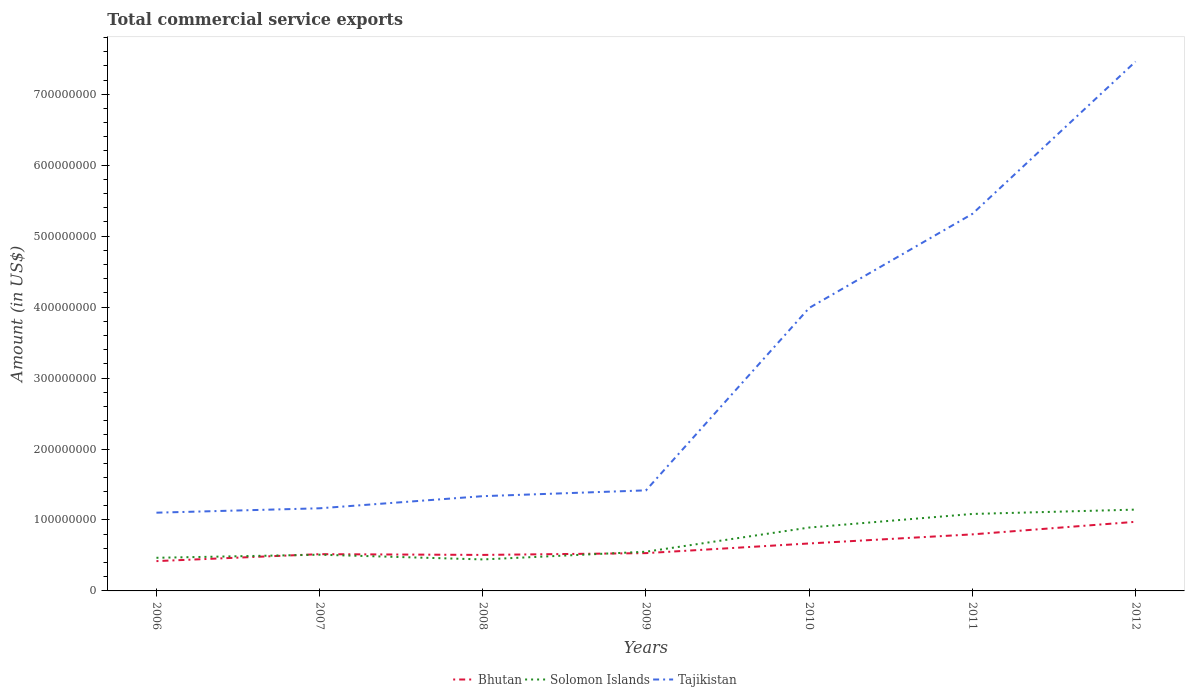How many different coloured lines are there?
Ensure brevity in your answer.  3. Is the number of lines equal to the number of legend labels?
Make the answer very short. Yes. Across all years, what is the maximum total commercial service exports in Solomon Islands?
Your response must be concise. 4.44e+07. In which year was the total commercial service exports in Tajikistan maximum?
Your response must be concise. 2006. What is the total total commercial service exports in Solomon Islands in the graph?
Give a very brief answer. -6.13e+06. What is the difference between the highest and the second highest total commercial service exports in Tajikistan?
Provide a short and direct response. 6.36e+08. What is the difference between the highest and the lowest total commercial service exports in Tajikistan?
Provide a succinct answer. 3. How many lines are there?
Your response must be concise. 3. How many years are there in the graph?
Give a very brief answer. 7. What is the difference between two consecutive major ticks on the Y-axis?
Provide a short and direct response. 1.00e+08. Are the values on the major ticks of Y-axis written in scientific E-notation?
Make the answer very short. No. How are the legend labels stacked?
Ensure brevity in your answer.  Horizontal. What is the title of the graph?
Keep it short and to the point. Total commercial service exports. Does "Liechtenstein" appear as one of the legend labels in the graph?
Your response must be concise. No. What is the label or title of the X-axis?
Offer a terse response. Years. What is the label or title of the Y-axis?
Offer a terse response. Amount (in US$). What is the Amount (in US$) of Bhutan in 2006?
Your response must be concise. 4.20e+07. What is the Amount (in US$) in Solomon Islands in 2006?
Give a very brief answer. 4.67e+07. What is the Amount (in US$) of Tajikistan in 2006?
Give a very brief answer. 1.10e+08. What is the Amount (in US$) of Bhutan in 2007?
Ensure brevity in your answer.  5.18e+07. What is the Amount (in US$) in Solomon Islands in 2007?
Your response must be concise. 5.10e+07. What is the Amount (in US$) in Tajikistan in 2007?
Your answer should be very brief. 1.16e+08. What is the Amount (in US$) of Bhutan in 2008?
Offer a terse response. 5.07e+07. What is the Amount (in US$) of Solomon Islands in 2008?
Your answer should be very brief. 4.44e+07. What is the Amount (in US$) of Tajikistan in 2008?
Give a very brief answer. 1.34e+08. What is the Amount (in US$) in Bhutan in 2009?
Give a very brief answer. 5.33e+07. What is the Amount (in US$) of Solomon Islands in 2009?
Ensure brevity in your answer.  5.53e+07. What is the Amount (in US$) of Tajikistan in 2009?
Make the answer very short. 1.42e+08. What is the Amount (in US$) in Bhutan in 2010?
Make the answer very short. 6.69e+07. What is the Amount (in US$) of Solomon Islands in 2010?
Provide a succinct answer. 8.93e+07. What is the Amount (in US$) in Tajikistan in 2010?
Provide a short and direct response. 3.99e+08. What is the Amount (in US$) in Bhutan in 2011?
Make the answer very short. 7.97e+07. What is the Amount (in US$) in Solomon Islands in 2011?
Provide a succinct answer. 1.08e+08. What is the Amount (in US$) in Tajikistan in 2011?
Your answer should be very brief. 5.31e+08. What is the Amount (in US$) in Bhutan in 2012?
Provide a succinct answer. 9.74e+07. What is the Amount (in US$) in Solomon Islands in 2012?
Your answer should be compact. 1.15e+08. What is the Amount (in US$) in Tajikistan in 2012?
Ensure brevity in your answer.  7.46e+08. Across all years, what is the maximum Amount (in US$) in Bhutan?
Offer a very short reply. 9.74e+07. Across all years, what is the maximum Amount (in US$) in Solomon Islands?
Offer a terse response. 1.15e+08. Across all years, what is the maximum Amount (in US$) of Tajikistan?
Make the answer very short. 7.46e+08. Across all years, what is the minimum Amount (in US$) of Bhutan?
Give a very brief answer. 4.20e+07. Across all years, what is the minimum Amount (in US$) of Solomon Islands?
Ensure brevity in your answer.  4.44e+07. Across all years, what is the minimum Amount (in US$) in Tajikistan?
Provide a succinct answer. 1.10e+08. What is the total Amount (in US$) in Bhutan in the graph?
Provide a short and direct response. 4.42e+08. What is the total Amount (in US$) in Solomon Islands in the graph?
Keep it short and to the point. 5.10e+08. What is the total Amount (in US$) of Tajikistan in the graph?
Your answer should be very brief. 2.18e+09. What is the difference between the Amount (in US$) in Bhutan in 2006 and that in 2007?
Make the answer very short. -9.80e+06. What is the difference between the Amount (in US$) in Solomon Islands in 2006 and that in 2007?
Keep it short and to the point. -4.36e+06. What is the difference between the Amount (in US$) in Tajikistan in 2006 and that in 2007?
Provide a short and direct response. -6.20e+06. What is the difference between the Amount (in US$) in Bhutan in 2006 and that in 2008?
Offer a terse response. -8.72e+06. What is the difference between the Amount (in US$) of Solomon Islands in 2006 and that in 2008?
Your answer should be compact. 2.32e+06. What is the difference between the Amount (in US$) of Tajikistan in 2006 and that in 2008?
Provide a succinct answer. -2.33e+07. What is the difference between the Amount (in US$) of Bhutan in 2006 and that in 2009?
Your answer should be very brief. -1.13e+07. What is the difference between the Amount (in US$) in Solomon Islands in 2006 and that in 2009?
Keep it short and to the point. -8.57e+06. What is the difference between the Amount (in US$) of Tajikistan in 2006 and that in 2009?
Provide a succinct answer. -3.15e+07. What is the difference between the Amount (in US$) of Bhutan in 2006 and that in 2010?
Offer a very short reply. -2.49e+07. What is the difference between the Amount (in US$) in Solomon Islands in 2006 and that in 2010?
Give a very brief answer. -4.26e+07. What is the difference between the Amount (in US$) in Tajikistan in 2006 and that in 2010?
Your answer should be very brief. -2.89e+08. What is the difference between the Amount (in US$) of Bhutan in 2006 and that in 2011?
Make the answer very short. -3.77e+07. What is the difference between the Amount (in US$) of Solomon Islands in 2006 and that in 2011?
Ensure brevity in your answer.  -6.18e+07. What is the difference between the Amount (in US$) of Tajikistan in 2006 and that in 2011?
Provide a short and direct response. -4.21e+08. What is the difference between the Amount (in US$) in Bhutan in 2006 and that in 2012?
Make the answer very short. -5.54e+07. What is the difference between the Amount (in US$) in Solomon Islands in 2006 and that in 2012?
Keep it short and to the point. -6.79e+07. What is the difference between the Amount (in US$) of Tajikistan in 2006 and that in 2012?
Your response must be concise. -6.36e+08. What is the difference between the Amount (in US$) in Bhutan in 2007 and that in 2008?
Ensure brevity in your answer.  1.08e+06. What is the difference between the Amount (in US$) of Solomon Islands in 2007 and that in 2008?
Make the answer very short. 6.67e+06. What is the difference between the Amount (in US$) in Tajikistan in 2007 and that in 2008?
Offer a terse response. -1.71e+07. What is the difference between the Amount (in US$) in Bhutan in 2007 and that in 2009?
Make the answer very short. -1.45e+06. What is the difference between the Amount (in US$) in Solomon Islands in 2007 and that in 2009?
Give a very brief answer. -4.21e+06. What is the difference between the Amount (in US$) in Tajikistan in 2007 and that in 2009?
Provide a succinct answer. -2.53e+07. What is the difference between the Amount (in US$) of Bhutan in 2007 and that in 2010?
Offer a very short reply. -1.51e+07. What is the difference between the Amount (in US$) in Solomon Islands in 2007 and that in 2010?
Your answer should be compact. -3.83e+07. What is the difference between the Amount (in US$) in Tajikistan in 2007 and that in 2010?
Offer a very short reply. -2.82e+08. What is the difference between the Amount (in US$) in Bhutan in 2007 and that in 2011?
Give a very brief answer. -2.79e+07. What is the difference between the Amount (in US$) of Solomon Islands in 2007 and that in 2011?
Provide a succinct answer. -5.74e+07. What is the difference between the Amount (in US$) of Tajikistan in 2007 and that in 2011?
Offer a very short reply. -4.15e+08. What is the difference between the Amount (in US$) of Bhutan in 2007 and that in 2012?
Your answer should be compact. -4.56e+07. What is the difference between the Amount (in US$) in Solomon Islands in 2007 and that in 2012?
Your response must be concise. -6.35e+07. What is the difference between the Amount (in US$) in Tajikistan in 2007 and that in 2012?
Make the answer very short. -6.30e+08. What is the difference between the Amount (in US$) in Bhutan in 2008 and that in 2009?
Your answer should be compact. -2.53e+06. What is the difference between the Amount (in US$) in Solomon Islands in 2008 and that in 2009?
Your answer should be compact. -1.09e+07. What is the difference between the Amount (in US$) in Tajikistan in 2008 and that in 2009?
Offer a very short reply. -8.19e+06. What is the difference between the Amount (in US$) in Bhutan in 2008 and that in 2010?
Provide a short and direct response. -1.62e+07. What is the difference between the Amount (in US$) of Solomon Islands in 2008 and that in 2010?
Ensure brevity in your answer.  -4.49e+07. What is the difference between the Amount (in US$) of Tajikistan in 2008 and that in 2010?
Your response must be concise. -2.65e+08. What is the difference between the Amount (in US$) of Bhutan in 2008 and that in 2011?
Your answer should be compact. -2.90e+07. What is the difference between the Amount (in US$) of Solomon Islands in 2008 and that in 2011?
Provide a succinct answer. -6.41e+07. What is the difference between the Amount (in US$) of Tajikistan in 2008 and that in 2011?
Offer a very short reply. -3.98e+08. What is the difference between the Amount (in US$) of Bhutan in 2008 and that in 2012?
Ensure brevity in your answer.  -4.67e+07. What is the difference between the Amount (in US$) of Solomon Islands in 2008 and that in 2012?
Provide a short and direct response. -7.02e+07. What is the difference between the Amount (in US$) of Tajikistan in 2008 and that in 2012?
Make the answer very short. -6.12e+08. What is the difference between the Amount (in US$) in Bhutan in 2009 and that in 2010?
Your answer should be very brief. -1.36e+07. What is the difference between the Amount (in US$) of Solomon Islands in 2009 and that in 2010?
Your response must be concise. -3.41e+07. What is the difference between the Amount (in US$) of Tajikistan in 2009 and that in 2010?
Make the answer very short. -2.57e+08. What is the difference between the Amount (in US$) of Bhutan in 2009 and that in 2011?
Offer a terse response. -2.64e+07. What is the difference between the Amount (in US$) of Solomon Islands in 2009 and that in 2011?
Your answer should be very brief. -5.32e+07. What is the difference between the Amount (in US$) in Tajikistan in 2009 and that in 2011?
Give a very brief answer. -3.90e+08. What is the difference between the Amount (in US$) of Bhutan in 2009 and that in 2012?
Your response must be concise. -4.41e+07. What is the difference between the Amount (in US$) in Solomon Islands in 2009 and that in 2012?
Your answer should be compact. -5.93e+07. What is the difference between the Amount (in US$) in Tajikistan in 2009 and that in 2012?
Provide a short and direct response. -6.04e+08. What is the difference between the Amount (in US$) in Bhutan in 2010 and that in 2011?
Your answer should be compact. -1.28e+07. What is the difference between the Amount (in US$) of Solomon Islands in 2010 and that in 2011?
Your answer should be compact. -1.91e+07. What is the difference between the Amount (in US$) of Tajikistan in 2010 and that in 2011?
Your response must be concise. -1.33e+08. What is the difference between the Amount (in US$) of Bhutan in 2010 and that in 2012?
Keep it short and to the point. -3.05e+07. What is the difference between the Amount (in US$) in Solomon Islands in 2010 and that in 2012?
Give a very brief answer. -2.53e+07. What is the difference between the Amount (in US$) of Tajikistan in 2010 and that in 2012?
Offer a terse response. -3.47e+08. What is the difference between the Amount (in US$) in Bhutan in 2011 and that in 2012?
Offer a terse response. -1.77e+07. What is the difference between the Amount (in US$) in Solomon Islands in 2011 and that in 2012?
Give a very brief answer. -6.13e+06. What is the difference between the Amount (in US$) in Tajikistan in 2011 and that in 2012?
Your answer should be compact. -2.15e+08. What is the difference between the Amount (in US$) of Bhutan in 2006 and the Amount (in US$) of Solomon Islands in 2007?
Provide a succinct answer. -9.04e+06. What is the difference between the Amount (in US$) of Bhutan in 2006 and the Amount (in US$) of Tajikistan in 2007?
Provide a short and direct response. -7.44e+07. What is the difference between the Amount (in US$) of Solomon Islands in 2006 and the Amount (in US$) of Tajikistan in 2007?
Provide a succinct answer. -6.98e+07. What is the difference between the Amount (in US$) of Bhutan in 2006 and the Amount (in US$) of Solomon Islands in 2008?
Your response must be concise. -2.36e+06. What is the difference between the Amount (in US$) of Bhutan in 2006 and the Amount (in US$) of Tajikistan in 2008?
Ensure brevity in your answer.  -9.15e+07. What is the difference between the Amount (in US$) of Solomon Islands in 2006 and the Amount (in US$) of Tajikistan in 2008?
Provide a succinct answer. -8.69e+07. What is the difference between the Amount (in US$) in Bhutan in 2006 and the Amount (in US$) in Solomon Islands in 2009?
Give a very brief answer. -1.32e+07. What is the difference between the Amount (in US$) of Bhutan in 2006 and the Amount (in US$) of Tajikistan in 2009?
Offer a very short reply. -9.97e+07. What is the difference between the Amount (in US$) in Solomon Islands in 2006 and the Amount (in US$) in Tajikistan in 2009?
Keep it short and to the point. -9.50e+07. What is the difference between the Amount (in US$) of Bhutan in 2006 and the Amount (in US$) of Solomon Islands in 2010?
Keep it short and to the point. -4.73e+07. What is the difference between the Amount (in US$) in Bhutan in 2006 and the Amount (in US$) in Tajikistan in 2010?
Ensure brevity in your answer.  -3.57e+08. What is the difference between the Amount (in US$) in Solomon Islands in 2006 and the Amount (in US$) in Tajikistan in 2010?
Give a very brief answer. -3.52e+08. What is the difference between the Amount (in US$) of Bhutan in 2006 and the Amount (in US$) of Solomon Islands in 2011?
Provide a succinct answer. -6.65e+07. What is the difference between the Amount (in US$) of Bhutan in 2006 and the Amount (in US$) of Tajikistan in 2011?
Keep it short and to the point. -4.89e+08. What is the difference between the Amount (in US$) of Solomon Islands in 2006 and the Amount (in US$) of Tajikistan in 2011?
Ensure brevity in your answer.  -4.85e+08. What is the difference between the Amount (in US$) in Bhutan in 2006 and the Amount (in US$) in Solomon Islands in 2012?
Give a very brief answer. -7.26e+07. What is the difference between the Amount (in US$) in Bhutan in 2006 and the Amount (in US$) in Tajikistan in 2012?
Provide a succinct answer. -7.04e+08. What is the difference between the Amount (in US$) of Solomon Islands in 2006 and the Amount (in US$) of Tajikistan in 2012?
Make the answer very short. -6.99e+08. What is the difference between the Amount (in US$) in Bhutan in 2007 and the Amount (in US$) in Solomon Islands in 2008?
Your answer should be very brief. 7.44e+06. What is the difference between the Amount (in US$) in Bhutan in 2007 and the Amount (in US$) in Tajikistan in 2008?
Make the answer very short. -8.17e+07. What is the difference between the Amount (in US$) in Solomon Islands in 2007 and the Amount (in US$) in Tajikistan in 2008?
Give a very brief answer. -8.25e+07. What is the difference between the Amount (in US$) in Bhutan in 2007 and the Amount (in US$) in Solomon Islands in 2009?
Give a very brief answer. -3.44e+06. What is the difference between the Amount (in US$) in Bhutan in 2007 and the Amount (in US$) in Tajikistan in 2009?
Make the answer very short. -8.99e+07. What is the difference between the Amount (in US$) of Solomon Islands in 2007 and the Amount (in US$) of Tajikistan in 2009?
Provide a succinct answer. -9.07e+07. What is the difference between the Amount (in US$) in Bhutan in 2007 and the Amount (in US$) in Solomon Islands in 2010?
Provide a short and direct response. -3.75e+07. What is the difference between the Amount (in US$) of Bhutan in 2007 and the Amount (in US$) of Tajikistan in 2010?
Offer a very short reply. -3.47e+08. What is the difference between the Amount (in US$) in Solomon Islands in 2007 and the Amount (in US$) in Tajikistan in 2010?
Your answer should be very brief. -3.48e+08. What is the difference between the Amount (in US$) in Bhutan in 2007 and the Amount (in US$) in Solomon Islands in 2011?
Your response must be concise. -5.66e+07. What is the difference between the Amount (in US$) in Bhutan in 2007 and the Amount (in US$) in Tajikistan in 2011?
Provide a succinct answer. -4.80e+08. What is the difference between the Amount (in US$) of Solomon Islands in 2007 and the Amount (in US$) of Tajikistan in 2011?
Your response must be concise. -4.80e+08. What is the difference between the Amount (in US$) in Bhutan in 2007 and the Amount (in US$) in Solomon Islands in 2012?
Offer a very short reply. -6.28e+07. What is the difference between the Amount (in US$) of Bhutan in 2007 and the Amount (in US$) of Tajikistan in 2012?
Your answer should be compact. -6.94e+08. What is the difference between the Amount (in US$) of Solomon Islands in 2007 and the Amount (in US$) of Tajikistan in 2012?
Ensure brevity in your answer.  -6.95e+08. What is the difference between the Amount (in US$) of Bhutan in 2008 and the Amount (in US$) of Solomon Islands in 2009?
Ensure brevity in your answer.  -4.53e+06. What is the difference between the Amount (in US$) of Bhutan in 2008 and the Amount (in US$) of Tajikistan in 2009?
Provide a succinct answer. -9.10e+07. What is the difference between the Amount (in US$) of Solomon Islands in 2008 and the Amount (in US$) of Tajikistan in 2009?
Keep it short and to the point. -9.74e+07. What is the difference between the Amount (in US$) in Bhutan in 2008 and the Amount (in US$) in Solomon Islands in 2010?
Your response must be concise. -3.86e+07. What is the difference between the Amount (in US$) in Bhutan in 2008 and the Amount (in US$) in Tajikistan in 2010?
Your answer should be compact. -3.48e+08. What is the difference between the Amount (in US$) of Solomon Islands in 2008 and the Amount (in US$) of Tajikistan in 2010?
Provide a short and direct response. -3.54e+08. What is the difference between the Amount (in US$) in Bhutan in 2008 and the Amount (in US$) in Solomon Islands in 2011?
Offer a terse response. -5.77e+07. What is the difference between the Amount (in US$) in Bhutan in 2008 and the Amount (in US$) in Tajikistan in 2011?
Ensure brevity in your answer.  -4.81e+08. What is the difference between the Amount (in US$) of Solomon Islands in 2008 and the Amount (in US$) of Tajikistan in 2011?
Give a very brief answer. -4.87e+08. What is the difference between the Amount (in US$) in Bhutan in 2008 and the Amount (in US$) in Solomon Islands in 2012?
Offer a very short reply. -6.39e+07. What is the difference between the Amount (in US$) of Bhutan in 2008 and the Amount (in US$) of Tajikistan in 2012?
Provide a succinct answer. -6.95e+08. What is the difference between the Amount (in US$) of Solomon Islands in 2008 and the Amount (in US$) of Tajikistan in 2012?
Make the answer very short. -7.02e+08. What is the difference between the Amount (in US$) of Bhutan in 2009 and the Amount (in US$) of Solomon Islands in 2010?
Your answer should be very brief. -3.61e+07. What is the difference between the Amount (in US$) of Bhutan in 2009 and the Amount (in US$) of Tajikistan in 2010?
Offer a terse response. -3.46e+08. What is the difference between the Amount (in US$) of Solomon Islands in 2009 and the Amount (in US$) of Tajikistan in 2010?
Keep it short and to the point. -3.44e+08. What is the difference between the Amount (in US$) in Bhutan in 2009 and the Amount (in US$) in Solomon Islands in 2011?
Your answer should be very brief. -5.52e+07. What is the difference between the Amount (in US$) of Bhutan in 2009 and the Amount (in US$) of Tajikistan in 2011?
Offer a very short reply. -4.78e+08. What is the difference between the Amount (in US$) of Solomon Islands in 2009 and the Amount (in US$) of Tajikistan in 2011?
Ensure brevity in your answer.  -4.76e+08. What is the difference between the Amount (in US$) in Bhutan in 2009 and the Amount (in US$) in Solomon Islands in 2012?
Offer a terse response. -6.13e+07. What is the difference between the Amount (in US$) in Bhutan in 2009 and the Amount (in US$) in Tajikistan in 2012?
Ensure brevity in your answer.  -6.93e+08. What is the difference between the Amount (in US$) of Solomon Islands in 2009 and the Amount (in US$) of Tajikistan in 2012?
Your response must be concise. -6.91e+08. What is the difference between the Amount (in US$) of Bhutan in 2010 and the Amount (in US$) of Solomon Islands in 2011?
Your response must be concise. -4.16e+07. What is the difference between the Amount (in US$) in Bhutan in 2010 and the Amount (in US$) in Tajikistan in 2011?
Your response must be concise. -4.64e+08. What is the difference between the Amount (in US$) of Solomon Islands in 2010 and the Amount (in US$) of Tajikistan in 2011?
Provide a succinct answer. -4.42e+08. What is the difference between the Amount (in US$) in Bhutan in 2010 and the Amount (in US$) in Solomon Islands in 2012?
Your answer should be very brief. -4.77e+07. What is the difference between the Amount (in US$) in Bhutan in 2010 and the Amount (in US$) in Tajikistan in 2012?
Your answer should be compact. -6.79e+08. What is the difference between the Amount (in US$) in Solomon Islands in 2010 and the Amount (in US$) in Tajikistan in 2012?
Your response must be concise. -6.57e+08. What is the difference between the Amount (in US$) of Bhutan in 2011 and the Amount (in US$) of Solomon Islands in 2012?
Provide a short and direct response. -3.49e+07. What is the difference between the Amount (in US$) in Bhutan in 2011 and the Amount (in US$) in Tajikistan in 2012?
Your answer should be compact. -6.66e+08. What is the difference between the Amount (in US$) of Solomon Islands in 2011 and the Amount (in US$) of Tajikistan in 2012?
Your answer should be very brief. -6.38e+08. What is the average Amount (in US$) in Bhutan per year?
Offer a terse response. 6.31e+07. What is the average Amount (in US$) in Solomon Islands per year?
Offer a very short reply. 7.28e+07. What is the average Amount (in US$) in Tajikistan per year?
Make the answer very short. 3.11e+08. In the year 2006, what is the difference between the Amount (in US$) in Bhutan and Amount (in US$) in Solomon Islands?
Your response must be concise. -4.68e+06. In the year 2006, what is the difference between the Amount (in US$) in Bhutan and Amount (in US$) in Tajikistan?
Ensure brevity in your answer.  -6.82e+07. In the year 2006, what is the difference between the Amount (in US$) of Solomon Islands and Amount (in US$) of Tajikistan?
Keep it short and to the point. -6.36e+07. In the year 2007, what is the difference between the Amount (in US$) in Bhutan and Amount (in US$) in Solomon Islands?
Provide a short and direct response. 7.69e+05. In the year 2007, what is the difference between the Amount (in US$) in Bhutan and Amount (in US$) in Tajikistan?
Offer a terse response. -6.46e+07. In the year 2007, what is the difference between the Amount (in US$) of Solomon Islands and Amount (in US$) of Tajikistan?
Ensure brevity in your answer.  -6.54e+07. In the year 2008, what is the difference between the Amount (in US$) in Bhutan and Amount (in US$) in Solomon Islands?
Keep it short and to the point. 6.36e+06. In the year 2008, what is the difference between the Amount (in US$) of Bhutan and Amount (in US$) of Tajikistan?
Your response must be concise. -8.28e+07. In the year 2008, what is the difference between the Amount (in US$) in Solomon Islands and Amount (in US$) in Tajikistan?
Your response must be concise. -8.92e+07. In the year 2009, what is the difference between the Amount (in US$) in Bhutan and Amount (in US$) in Solomon Islands?
Ensure brevity in your answer.  -2.00e+06. In the year 2009, what is the difference between the Amount (in US$) in Bhutan and Amount (in US$) in Tajikistan?
Make the answer very short. -8.85e+07. In the year 2009, what is the difference between the Amount (in US$) of Solomon Islands and Amount (in US$) of Tajikistan?
Ensure brevity in your answer.  -8.65e+07. In the year 2010, what is the difference between the Amount (in US$) in Bhutan and Amount (in US$) in Solomon Islands?
Keep it short and to the point. -2.24e+07. In the year 2010, what is the difference between the Amount (in US$) of Bhutan and Amount (in US$) of Tajikistan?
Make the answer very short. -3.32e+08. In the year 2010, what is the difference between the Amount (in US$) of Solomon Islands and Amount (in US$) of Tajikistan?
Make the answer very short. -3.09e+08. In the year 2011, what is the difference between the Amount (in US$) of Bhutan and Amount (in US$) of Solomon Islands?
Ensure brevity in your answer.  -2.88e+07. In the year 2011, what is the difference between the Amount (in US$) in Bhutan and Amount (in US$) in Tajikistan?
Provide a succinct answer. -4.52e+08. In the year 2011, what is the difference between the Amount (in US$) in Solomon Islands and Amount (in US$) in Tajikistan?
Your response must be concise. -4.23e+08. In the year 2012, what is the difference between the Amount (in US$) in Bhutan and Amount (in US$) in Solomon Islands?
Give a very brief answer. -1.72e+07. In the year 2012, what is the difference between the Amount (in US$) in Bhutan and Amount (in US$) in Tajikistan?
Your answer should be compact. -6.49e+08. In the year 2012, what is the difference between the Amount (in US$) of Solomon Islands and Amount (in US$) of Tajikistan?
Ensure brevity in your answer.  -6.31e+08. What is the ratio of the Amount (in US$) in Bhutan in 2006 to that in 2007?
Your answer should be compact. 0.81. What is the ratio of the Amount (in US$) of Solomon Islands in 2006 to that in 2007?
Keep it short and to the point. 0.91. What is the ratio of the Amount (in US$) in Tajikistan in 2006 to that in 2007?
Offer a terse response. 0.95. What is the ratio of the Amount (in US$) of Bhutan in 2006 to that in 2008?
Ensure brevity in your answer.  0.83. What is the ratio of the Amount (in US$) of Solomon Islands in 2006 to that in 2008?
Keep it short and to the point. 1.05. What is the ratio of the Amount (in US$) of Tajikistan in 2006 to that in 2008?
Ensure brevity in your answer.  0.83. What is the ratio of the Amount (in US$) of Bhutan in 2006 to that in 2009?
Offer a very short reply. 0.79. What is the ratio of the Amount (in US$) of Solomon Islands in 2006 to that in 2009?
Your response must be concise. 0.84. What is the ratio of the Amount (in US$) of Tajikistan in 2006 to that in 2009?
Your response must be concise. 0.78. What is the ratio of the Amount (in US$) in Bhutan in 2006 to that in 2010?
Ensure brevity in your answer.  0.63. What is the ratio of the Amount (in US$) of Solomon Islands in 2006 to that in 2010?
Ensure brevity in your answer.  0.52. What is the ratio of the Amount (in US$) in Tajikistan in 2006 to that in 2010?
Your answer should be very brief. 0.28. What is the ratio of the Amount (in US$) of Bhutan in 2006 to that in 2011?
Your answer should be compact. 0.53. What is the ratio of the Amount (in US$) of Solomon Islands in 2006 to that in 2011?
Provide a succinct answer. 0.43. What is the ratio of the Amount (in US$) of Tajikistan in 2006 to that in 2011?
Give a very brief answer. 0.21. What is the ratio of the Amount (in US$) of Bhutan in 2006 to that in 2012?
Keep it short and to the point. 0.43. What is the ratio of the Amount (in US$) in Solomon Islands in 2006 to that in 2012?
Offer a terse response. 0.41. What is the ratio of the Amount (in US$) in Tajikistan in 2006 to that in 2012?
Your answer should be compact. 0.15. What is the ratio of the Amount (in US$) of Bhutan in 2007 to that in 2008?
Your answer should be very brief. 1.02. What is the ratio of the Amount (in US$) of Solomon Islands in 2007 to that in 2008?
Offer a terse response. 1.15. What is the ratio of the Amount (in US$) of Tajikistan in 2007 to that in 2008?
Provide a succinct answer. 0.87. What is the ratio of the Amount (in US$) in Bhutan in 2007 to that in 2009?
Ensure brevity in your answer.  0.97. What is the ratio of the Amount (in US$) of Solomon Islands in 2007 to that in 2009?
Ensure brevity in your answer.  0.92. What is the ratio of the Amount (in US$) in Tajikistan in 2007 to that in 2009?
Your answer should be very brief. 0.82. What is the ratio of the Amount (in US$) of Bhutan in 2007 to that in 2010?
Provide a short and direct response. 0.77. What is the ratio of the Amount (in US$) of Solomon Islands in 2007 to that in 2010?
Ensure brevity in your answer.  0.57. What is the ratio of the Amount (in US$) of Tajikistan in 2007 to that in 2010?
Make the answer very short. 0.29. What is the ratio of the Amount (in US$) in Bhutan in 2007 to that in 2011?
Offer a terse response. 0.65. What is the ratio of the Amount (in US$) in Solomon Islands in 2007 to that in 2011?
Make the answer very short. 0.47. What is the ratio of the Amount (in US$) in Tajikistan in 2007 to that in 2011?
Provide a succinct answer. 0.22. What is the ratio of the Amount (in US$) in Bhutan in 2007 to that in 2012?
Give a very brief answer. 0.53. What is the ratio of the Amount (in US$) of Solomon Islands in 2007 to that in 2012?
Your response must be concise. 0.45. What is the ratio of the Amount (in US$) of Tajikistan in 2007 to that in 2012?
Offer a terse response. 0.16. What is the ratio of the Amount (in US$) in Solomon Islands in 2008 to that in 2009?
Offer a terse response. 0.8. What is the ratio of the Amount (in US$) of Tajikistan in 2008 to that in 2009?
Give a very brief answer. 0.94. What is the ratio of the Amount (in US$) in Bhutan in 2008 to that in 2010?
Ensure brevity in your answer.  0.76. What is the ratio of the Amount (in US$) of Solomon Islands in 2008 to that in 2010?
Give a very brief answer. 0.5. What is the ratio of the Amount (in US$) of Tajikistan in 2008 to that in 2010?
Ensure brevity in your answer.  0.33. What is the ratio of the Amount (in US$) of Bhutan in 2008 to that in 2011?
Keep it short and to the point. 0.64. What is the ratio of the Amount (in US$) of Solomon Islands in 2008 to that in 2011?
Offer a very short reply. 0.41. What is the ratio of the Amount (in US$) in Tajikistan in 2008 to that in 2011?
Give a very brief answer. 0.25. What is the ratio of the Amount (in US$) of Bhutan in 2008 to that in 2012?
Provide a succinct answer. 0.52. What is the ratio of the Amount (in US$) of Solomon Islands in 2008 to that in 2012?
Ensure brevity in your answer.  0.39. What is the ratio of the Amount (in US$) of Tajikistan in 2008 to that in 2012?
Provide a short and direct response. 0.18. What is the ratio of the Amount (in US$) of Bhutan in 2009 to that in 2010?
Give a very brief answer. 0.8. What is the ratio of the Amount (in US$) in Solomon Islands in 2009 to that in 2010?
Your answer should be compact. 0.62. What is the ratio of the Amount (in US$) in Tajikistan in 2009 to that in 2010?
Keep it short and to the point. 0.36. What is the ratio of the Amount (in US$) in Bhutan in 2009 to that in 2011?
Offer a terse response. 0.67. What is the ratio of the Amount (in US$) of Solomon Islands in 2009 to that in 2011?
Offer a very short reply. 0.51. What is the ratio of the Amount (in US$) in Tajikistan in 2009 to that in 2011?
Offer a terse response. 0.27. What is the ratio of the Amount (in US$) of Bhutan in 2009 to that in 2012?
Provide a short and direct response. 0.55. What is the ratio of the Amount (in US$) in Solomon Islands in 2009 to that in 2012?
Your response must be concise. 0.48. What is the ratio of the Amount (in US$) of Tajikistan in 2009 to that in 2012?
Your answer should be compact. 0.19. What is the ratio of the Amount (in US$) of Bhutan in 2010 to that in 2011?
Your answer should be very brief. 0.84. What is the ratio of the Amount (in US$) of Solomon Islands in 2010 to that in 2011?
Offer a very short reply. 0.82. What is the ratio of the Amount (in US$) of Tajikistan in 2010 to that in 2011?
Provide a succinct answer. 0.75. What is the ratio of the Amount (in US$) of Bhutan in 2010 to that in 2012?
Your answer should be compact. 0.69. What is the ratio of the Amount (in US$) of Solomon Islands in 2010 to that in 2012?
Make the answer very short. 0.78. What is the ratio of the Amount (in US$) in Tajikistan in 2010 to that in 2012?
Provide a short and direct response. 0.53. What is the ratio of the Amount (in US$) in Bhutan in 2011 to that in 2012?
Offer a terse response. 0.82. What is the ratio of the Amount (in US$) of Solomon Islands in 2011 to that in 2012?
Your response must be concise. 0.95. What is the ratio of the Amount (in US$) of Tajikistan in 2011 to that in 2012?
Offer a very short reply. 0.71. What is the difference between the highest and the second highest Amount (in US$) in Bhutan?
Make the answer very short. 1.77e+07. What is the difference between the highest and the second highest Amount (in US$) in Solomon Islands?
Make the answer very short. 6.13e+06. What is the difference between the highest and the second highest Amount (in US$) of Tajikistan?
Keep it short and to the point. 2.15e+08. What is the difference between the highest and the lowest Amount (in US$) of Bhutan?
Your response must be concise. 5.54e+07. What is the difference between the highest and the lowest Amount (in US$) in Solomon Islands?
Ensure brevity in your answer.  7.02e+07. What is the difference between the highest and the lowest Amount (in US$) of Tajikistan?
Give a very brief answer. 6.36e+08. 